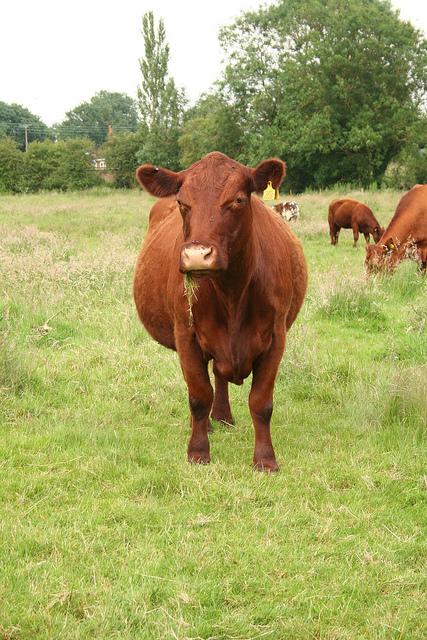What color is the cow?
Keep it brief. Brown. What is hanging from the cow's ear?
Quick response, please. Tag. Do these cows have enough to eat?
Concise answer only. Yes. 